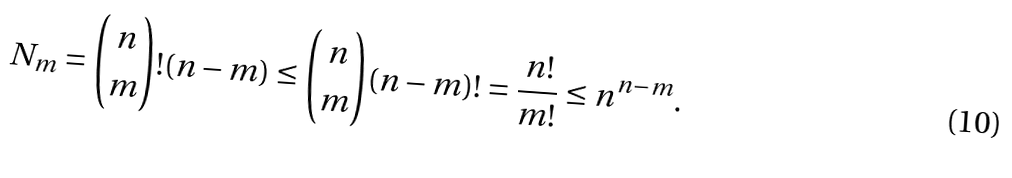Convert formula to latex. <formula><loc_0><loc_0><loc_500><loc_500>N _ { m } = { n \choose m } ! ( n - m ) \leq { n \choose m } ( n - m ) ! = \frac { n ! } { m ! } \leq n ^ { n - m } .</formula> 